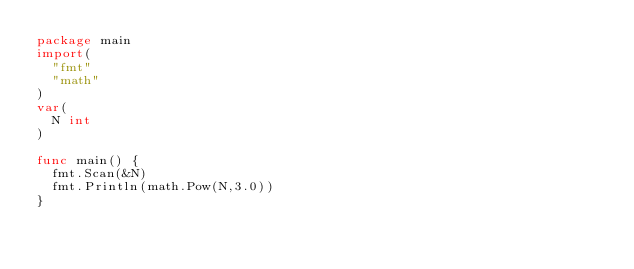Convert code to text. <code><loc_0><loc_0><loc_500><loc_500><_Go_>package main
import(
  "fmt"
  "math"
)
var(
  N int
)

func main() {
  fmt.Scan(&N)
  fmt.Println(math.Pow(N,3.0))
}</code> 